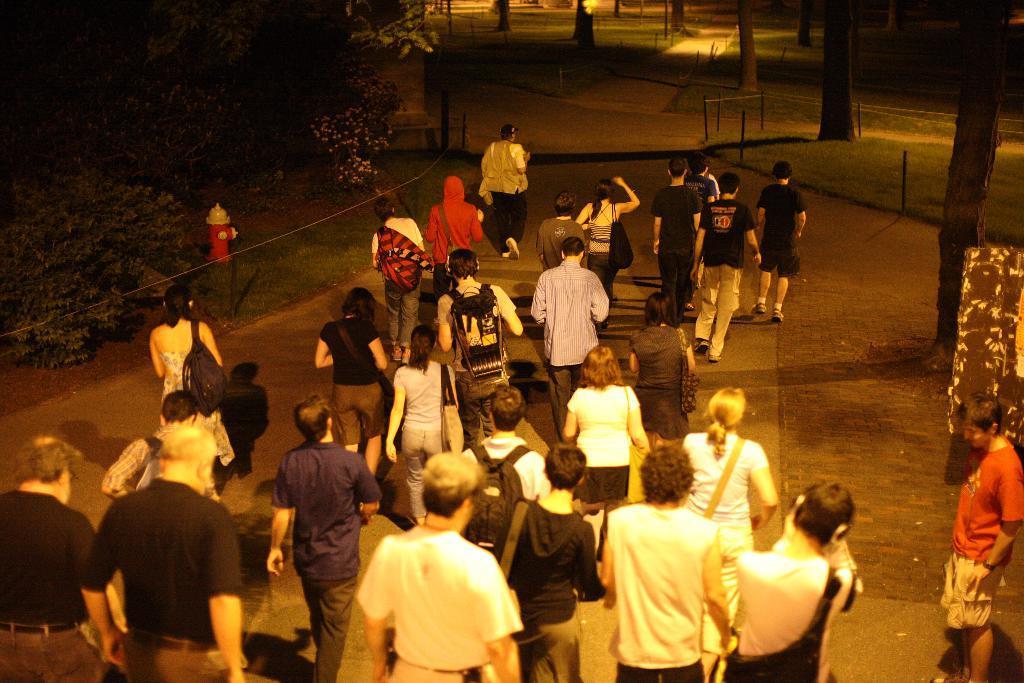Please provide a concise description of this image. In the picture we can see a public are walking on the path, besides, we can see some grass surface with some plants and trees and in the background also we can see some path with grass and poles. 